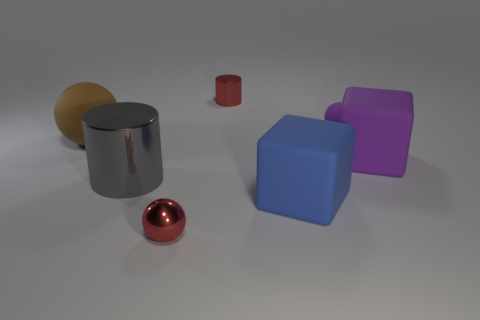Add 2 blue rubber things. How many objects exist? 9 Subtract all cylinders. How many objects are left? 5 Add 3 purple metal objects. How many purple metal objects exist? 3 Subtract 1 brown spheres. How many objects are left? 6 Subtract all small cyan matte cylinders. Subtract all matte blocks. How many objects are left? 5 Add 1 small metal balls. How many small metal balls are left? 2 